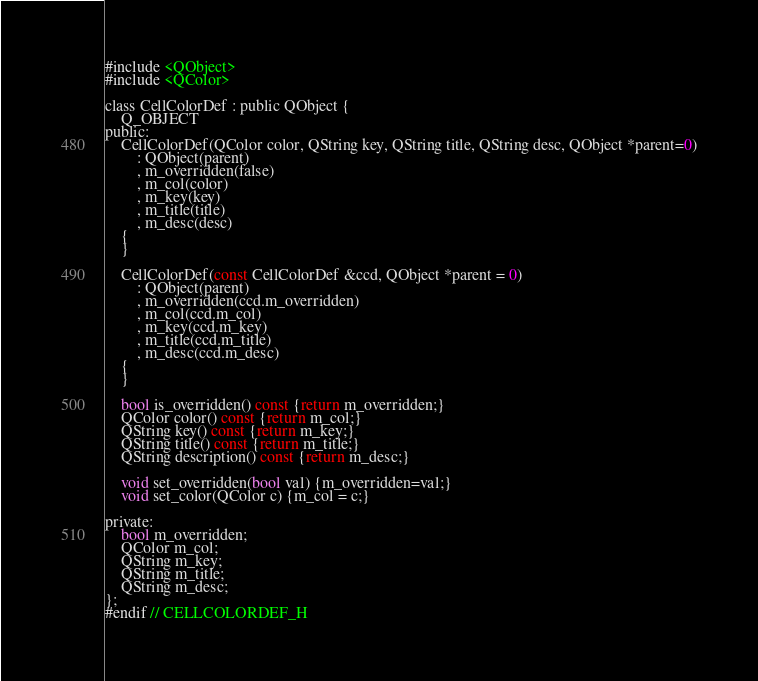<code> <loc_0><loc_0><loc_500><loc_500><_C_>#include <QObject>
#include <QColor>

class CellColorDef : public QObject {
    Q_OBJECT
public:
    CellColorDef(QColor color, QString key, QString title, QString desc, QObject *parent=0)
        : QObject(parent)
        , m_overridden(false)
        , m_col(color)
        , m_key(key)
        , m_title(title)
        , m_desc(desc)
    {
    }

    CellColorDef(const CellColorDef &ccd, QObject *parent = 0)
        : QObject(parent)
        , m_overridden(ccd.m_overridden)
        , m_col(ccd.m_col)
        , m_key(ccd.m_key)
        , m_title(ccd.m_title)
        , m_desc(ccd.m_desc)
    {
    }

    bool is_overridden() const {return m_overridden;}
    QColor color() const {return m_col;}
    QString key() const {return m_key;}
    QString title() const {return m_title;}
    QString description() const {return m_desc;}

    void set_overridden(bool val) {m_overridden=val;}
    void set_color(QColor c) {m_col = c;}

private:
    bool m_overridden;
    QColor m_col;
    QString m_key;
    QString m_title;
    QString m_desc;
};
#endif // CELLCOLORDEF_H
</code> 